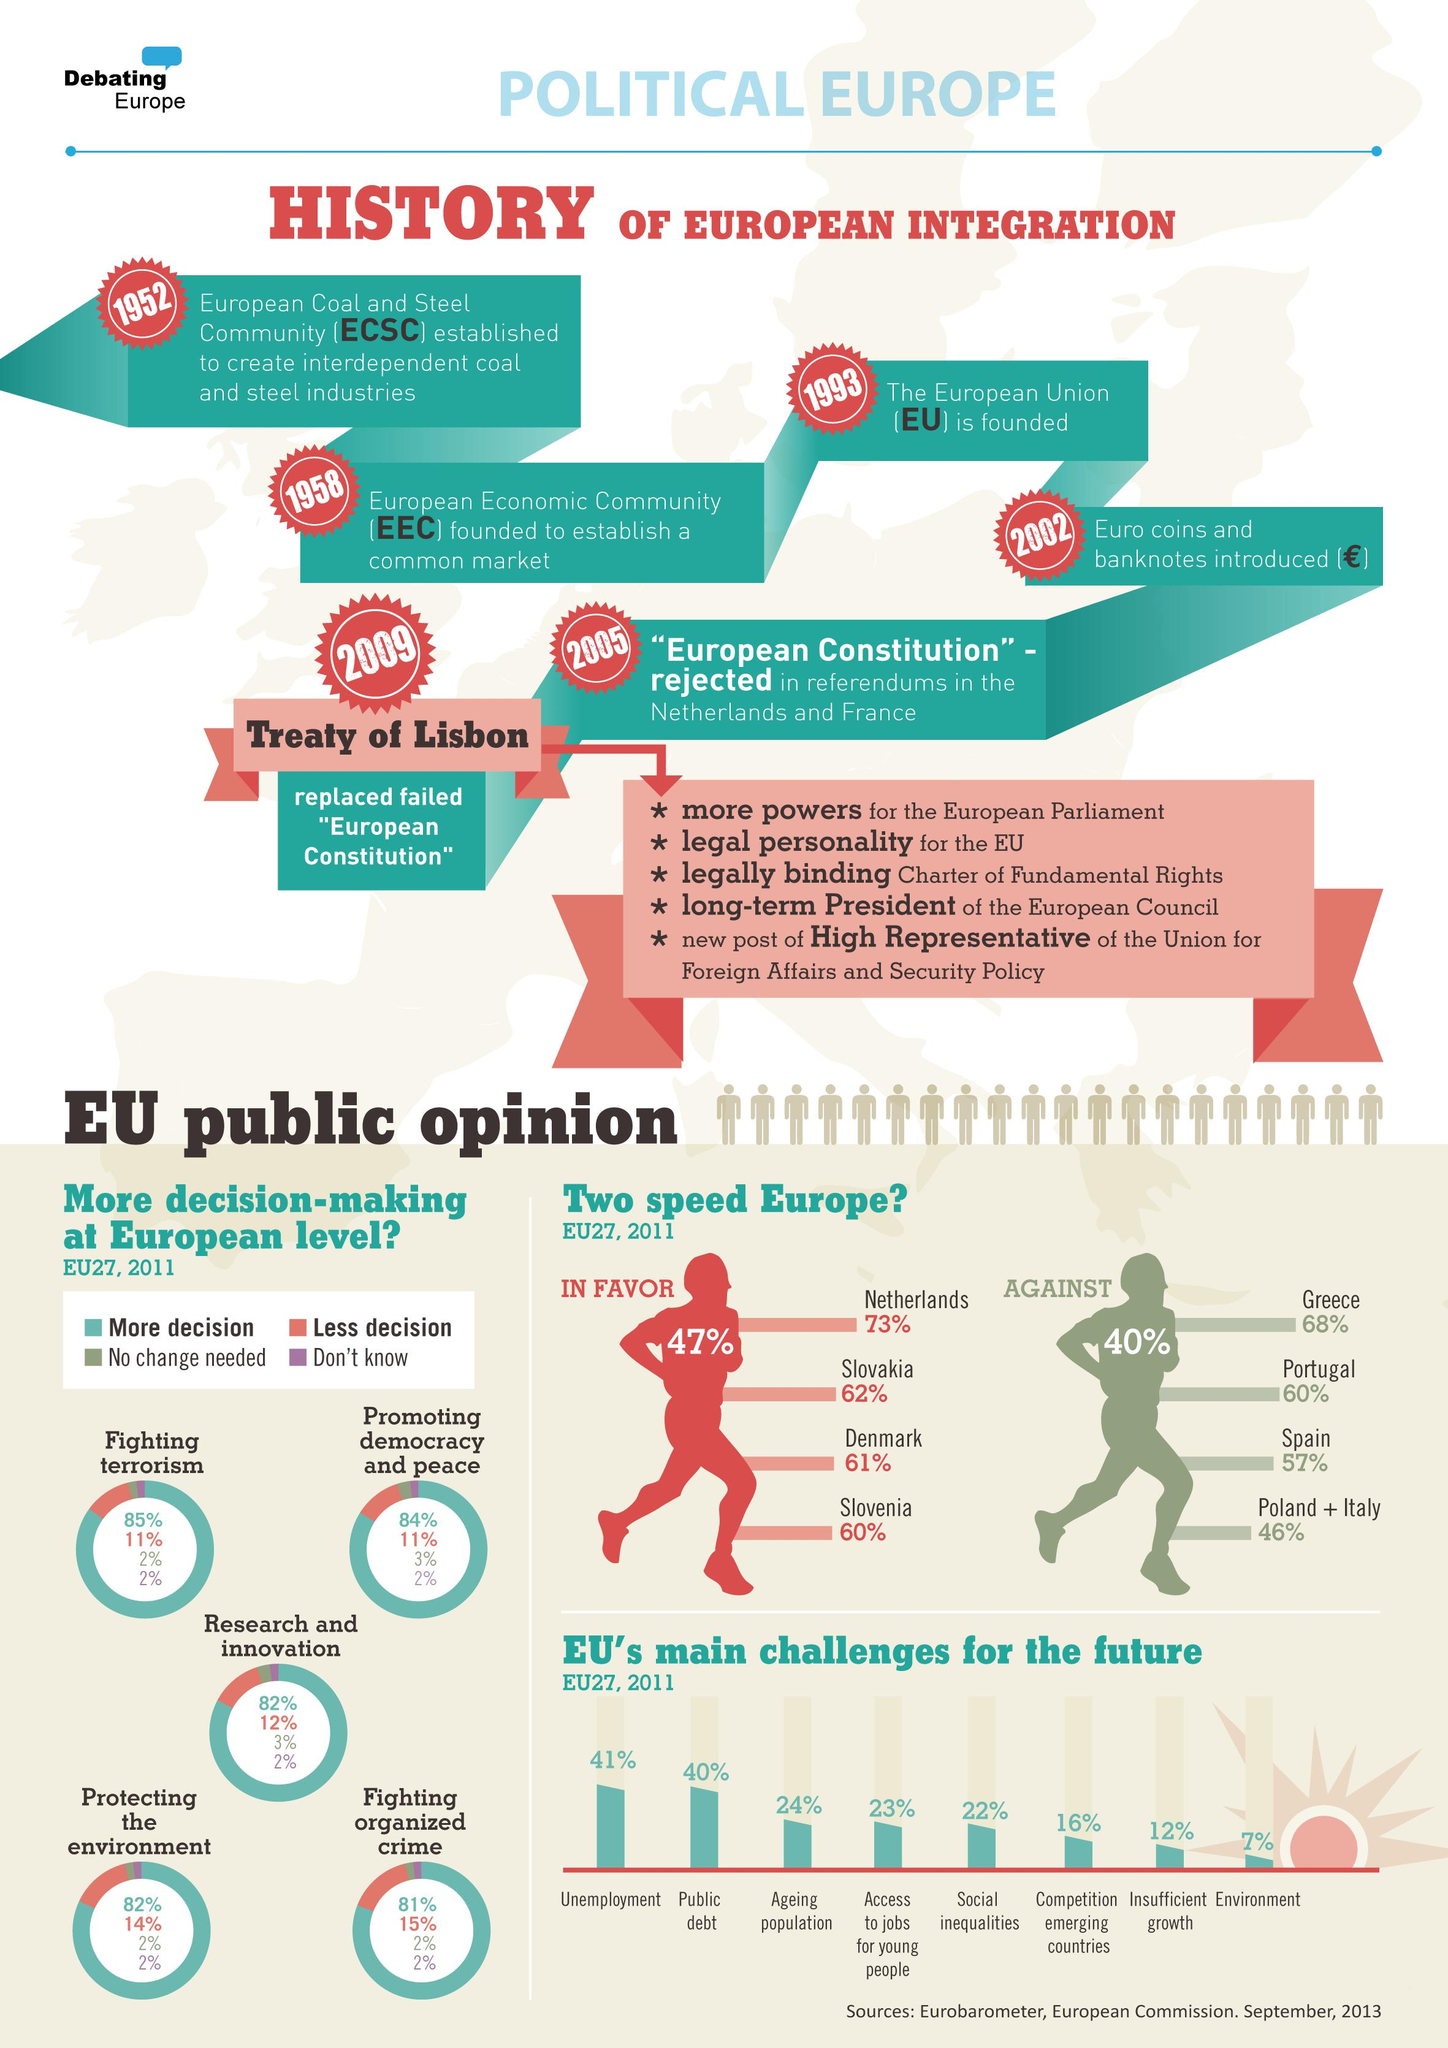Point out several critical features in this image. The first two main challenges for the European Union in the future are unemployment and public debt. The Treaty of Lisbon was finalized in 2009. There are five points in the Treaty of Lisbon. Poland and Italy were joined by Greece, Portugal, and Spain in opposing the two-speed Europe, a concept that envisions a faster integration for some EU members while others lag behind. The euro coins and bank notes were introduced 50 years after the establishment of the ECSC. 